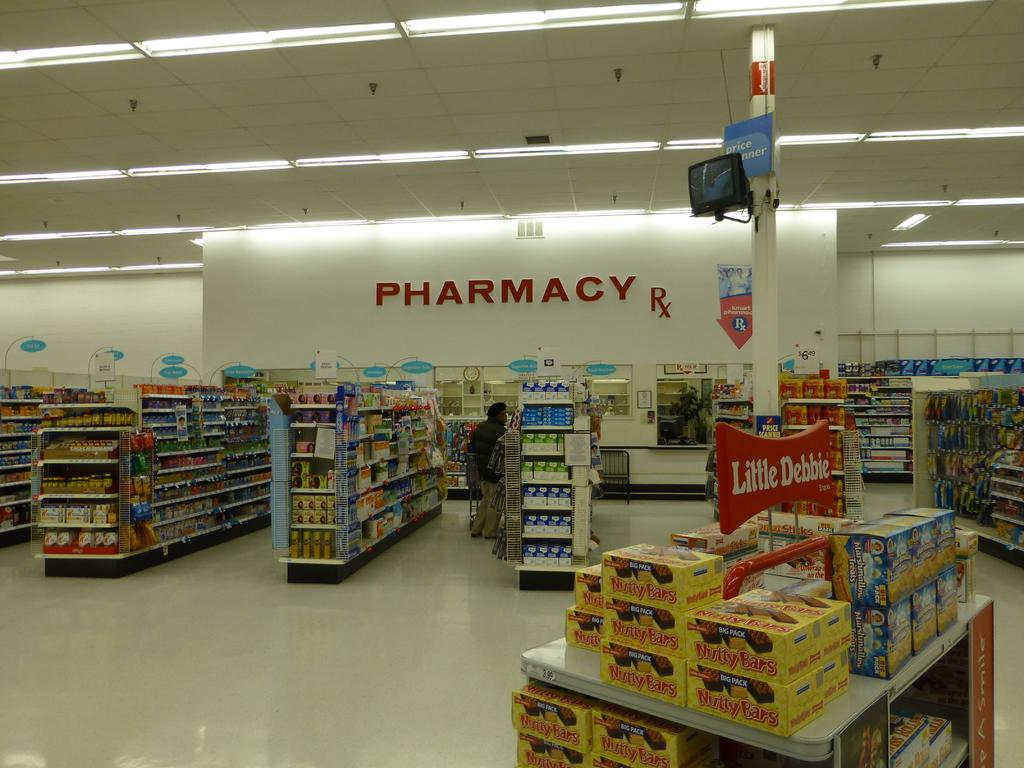Provide a one-sentence caption for the provided image. A pharmacy sign inside of a grocery store showcasing many products. 